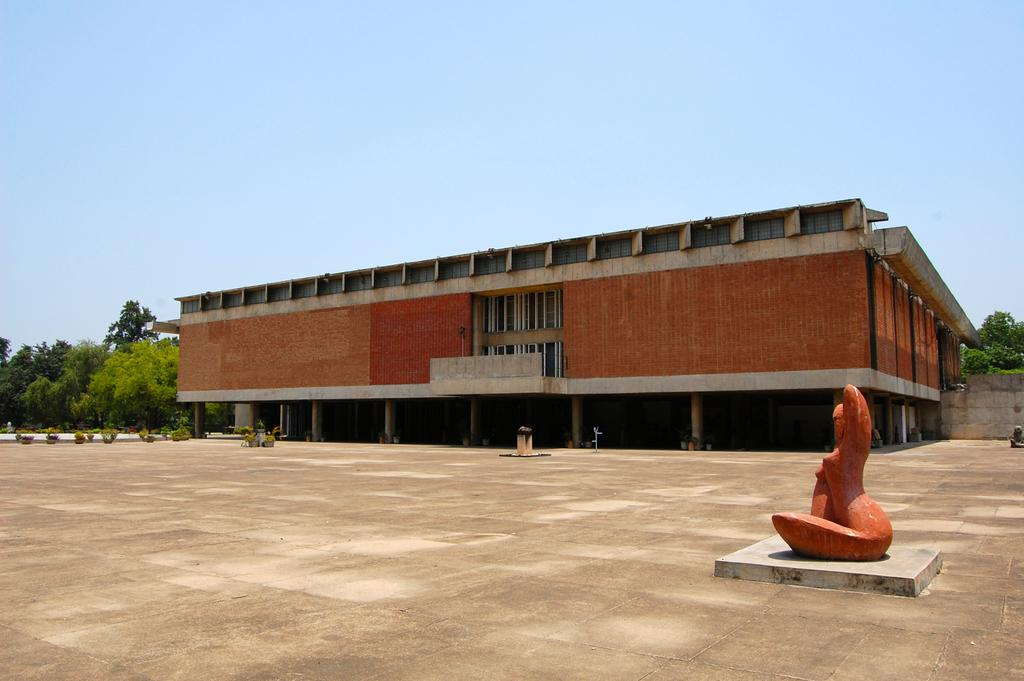What is the main subject in the foreground of the image? There is a sculpture in the foreground of the image. Where is the sculpture located in relation to the image? The sculpture is on the right side. What can be seen in the background of the image? There is a building, plants, the ground, trees, and the sky visible in the background of the image. What type of corn is being harvested in the image? There is no corn present in the image; it features a sculpture in the foreground and various elements in the background. What nation is depicted in the image? The image does not depict any specific nation; it is a scene with a sculpture, a building, plants, the ground, trees, and the sky. 